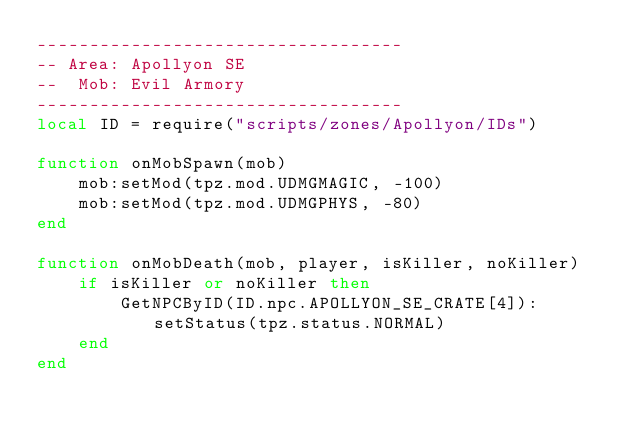<code> <loc_0><loc_0><loc_500><loc_500><_Lua_>-----------------------------------
-- Area: Apollyon SE
--  Mob: Evil Armory
-----------------------------------
local ID = require("scripts/zones/Apollyon/IDs")

function onMobSpawn(mob)
    mob:setMod(tpz.mod.UDMGMAGIC, -100)
    mob:setMod(tpz.mod.UDMGPHYS, -80)
end

function onMobDeath(mob, player, isKiller, noKiller)
    if isKiller or noKiller then
        GetNPCByID(ID.npc.APOLLYON_SE_CRATE[4]):setStatus(tpz.status.NORMAL)
    end
end
</code> 